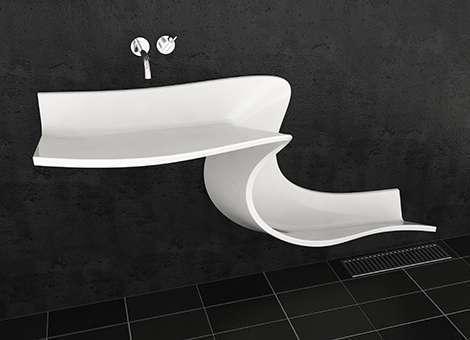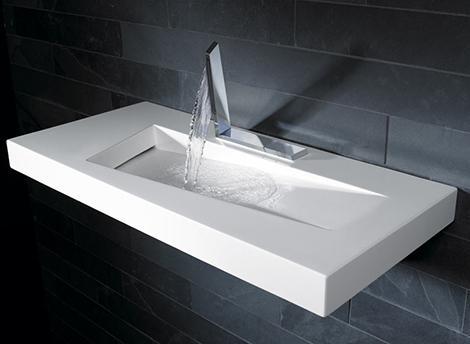The first image is the image on the left, the second image is the image on the right. Given the left and right images, does the statement "One sink is a white squiggle and one sink is hollowed out from a white rectangular block." hold true? Answer yes or no. Yes. The first image is the image on the left, the second image is the image on the right. For the images displayed, is the sentence "The sink in the image on the left curves down toward the floor." factually correct? Answer yes or no. Yes. 